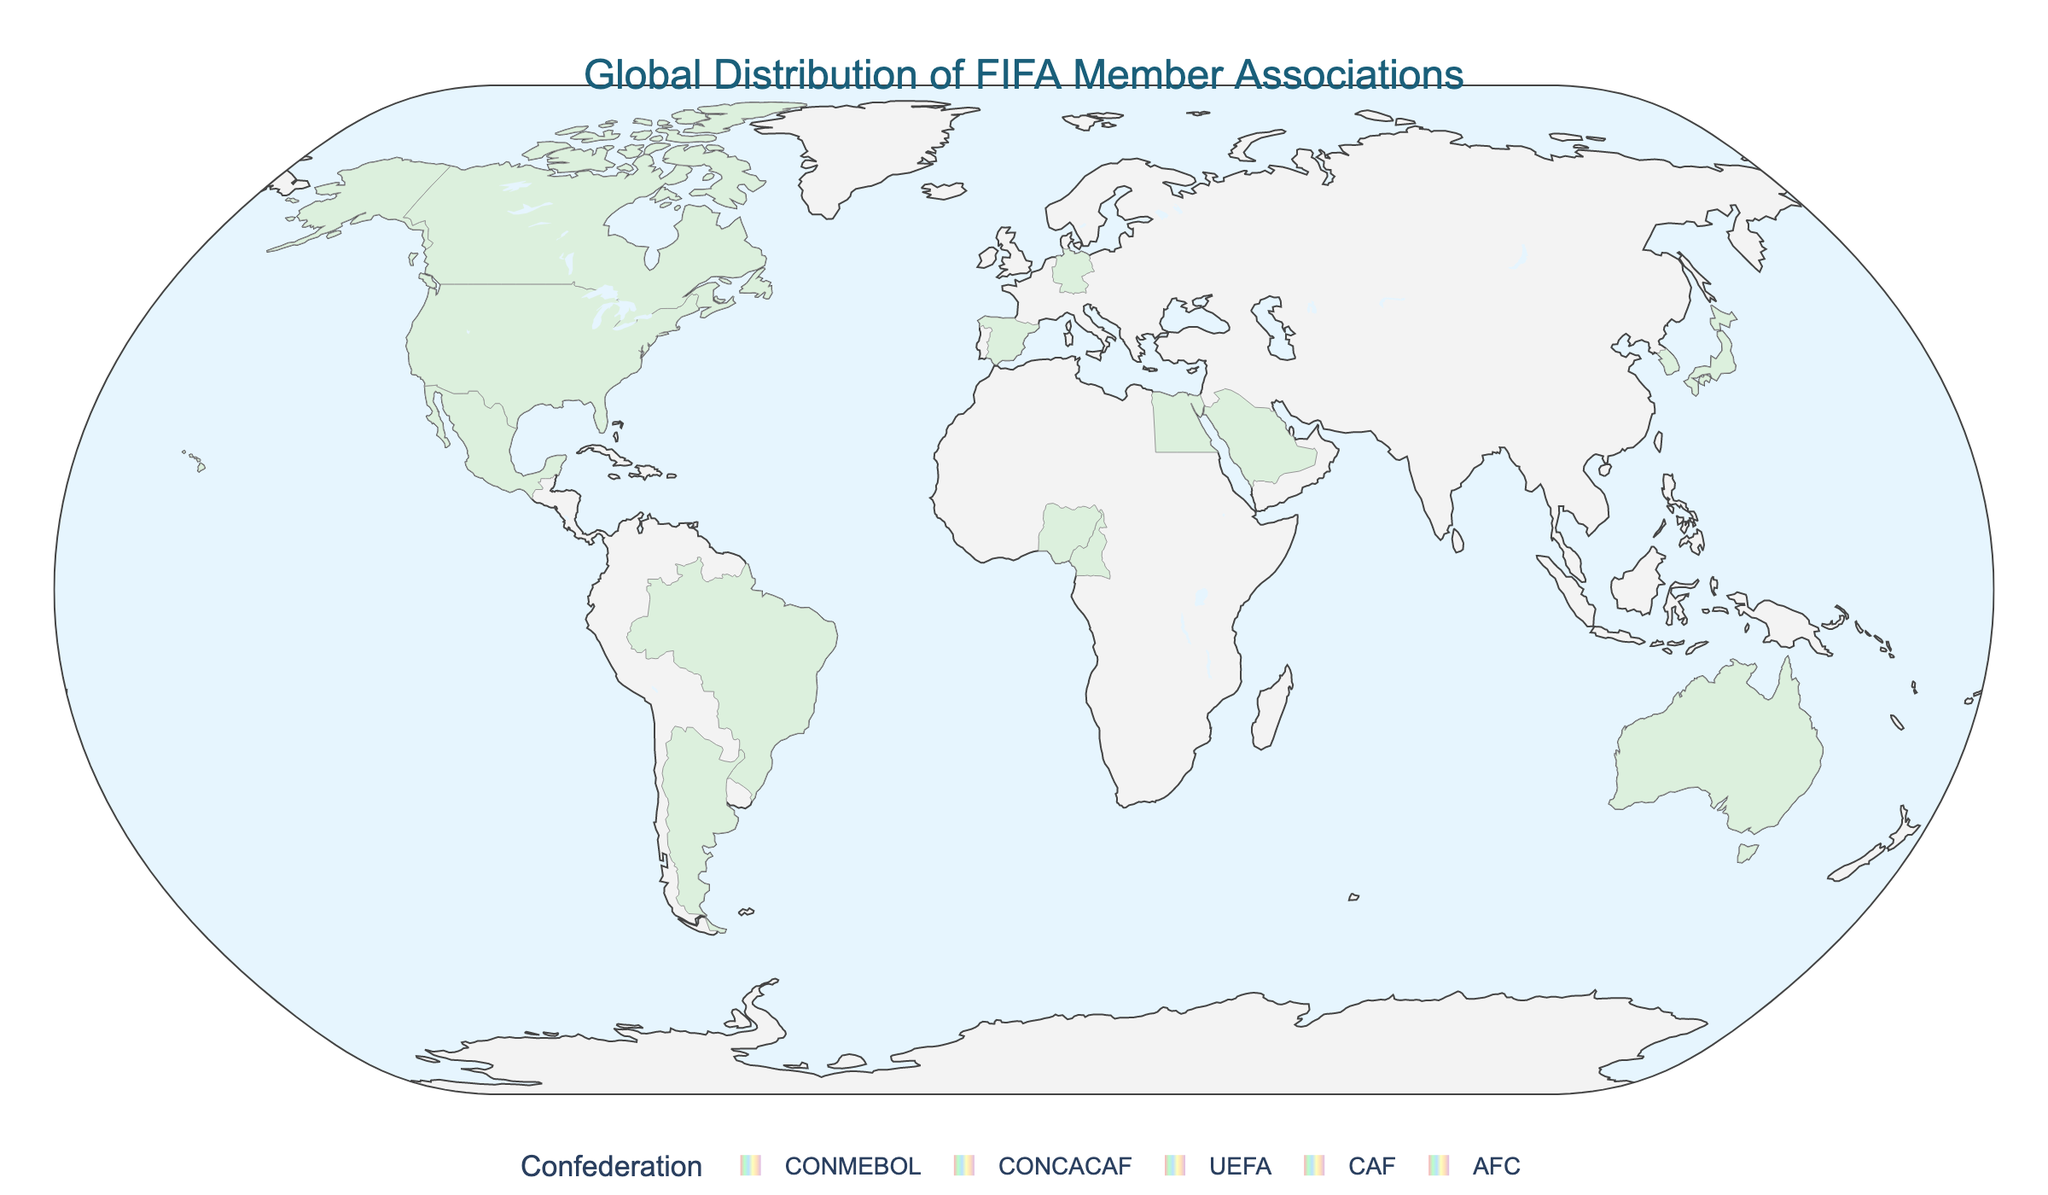How many continents are represented by the confederations on the map? First, identify the regions associated with each confederation: CONMEBOL (South America), CONCACAF (North America), UEFA (Europe), CAF (Africa), AFC (Asia, Oceania). This sums up to five distinct continents.
Answer: 5 Which continent has the highest number of FIFA members according to the map? Examine the member counts per confederation. UEFA (Europe) and CAF (Africa) have 55 members each, the highest among the confederations.
Answer: Europe and Africa Compare the number of FIFA members in North America and South America. Which has more? North America (CONCACAF) has 41 members. South America (CONMEBOL) has 10 members. Thus, North America has more members.
Answer: North America What is the total number of FIFA members for AFC? All AFC members, including Asia and Oceania, sum up to a total. AFC has 47 members.
Answer: 47 Which country in the UEFA confederation is represented on the map? The countries listed under UEFA in the data are England, Germany, and Spain.
Answer: England, Germany, Spain What can you observe about the color scheme used in the map? The map uses varying shades of colors to distinguish different confederations. Each confederation has a distinct color.
Answer: Different colors for each confederation Is there any confederation that spans more than one continent? The AFC confederation spans two continents: Asia and Oceania.
Answer: AFC How many countries are represented by the CONMEBOL confederation in the map? Count the countries listed under CONMEBOL in the data: Brazil and Argentina, making a total of 10 members.
Answer: 2 What is the total number of FIFA members represented on the map? Add up the count of members from each confederation: 10 (CONMEBOL) + 41 (CONCACAF) + 55 (UEFA) + 54 (CAF) + 47 (AFC) = 207.
Answer: 207 Which confederation has the least number of members shown on the map? The CONMEBOL confederation, with only 10 members, has the least number of members.
Answer: CONMEBOL 